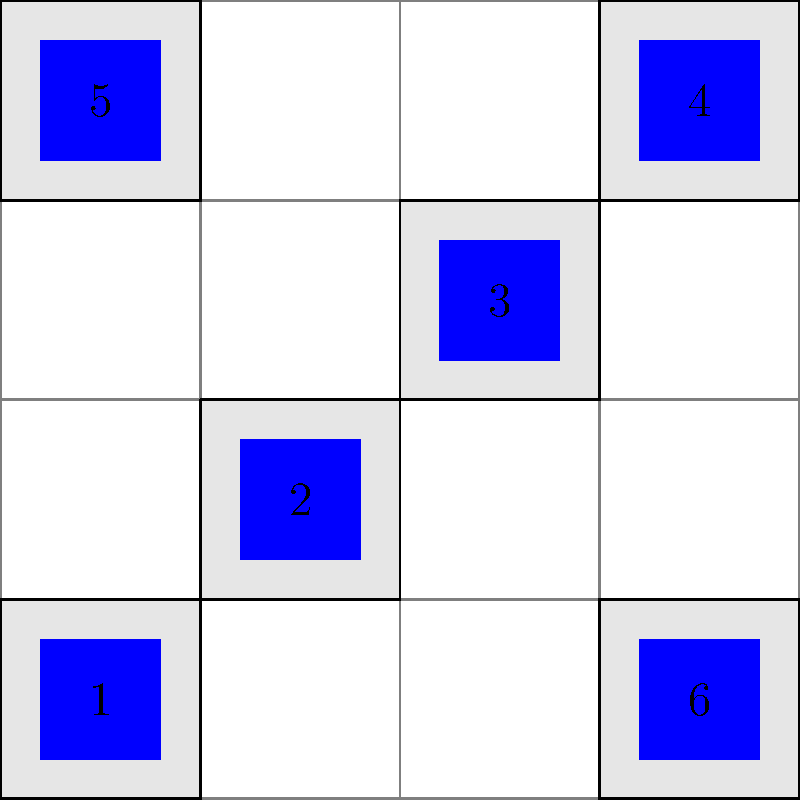Given the city grid layout shown above, where blue squares represent solar panels on building rooftops numbered 1 to 6, what is the minimum number of power distribution centers needed to ensure that each solar panel is connected to a distribution center, if each center can only connect to panels within a 1-block radius (including diagonally)? To solve this problem, we need to analyze the layout and determine the minimum number of distribution centers that can cover all solar panels within a 1-block radius. Let's approach this step-by-step:

1. First, let's identify the coverage area for each potential distribution center:
   - A center at building 1 would cover panels 1 and 2
   - A center at building 2 would cover panels 1, 2, and 3
   - A center at building 3 would cover panels 2, 3, and 4
   - A center at building 4 would cover panels 3 and 4
   - A center at building 5 would only cover panel 5
   - A center at building 6 would only cover panel 6

2. We can see that panels 5 and 6 are isolated and will each require their own distribution center.

3. For the remaining panels (1, 2, 3, and 4), we need to find the minimum number of centers to cover them all.

4. We can cover panels 1, 2, and 3 with a single center at building 2.

5. Panel 4 can be covered by placing a center at building 4.

6. Therefore, the optimal solution is:
   - One center at building 2 (covering panels 1, 2, and 3)
   - One center at building 4 (covering panel 4)
   - One center at building 5 (covering panel 5)
   - One center at building 6 (covering panel 6)

Thus, the minimum number of power distribution centers needed is 4.
Answer: 4 